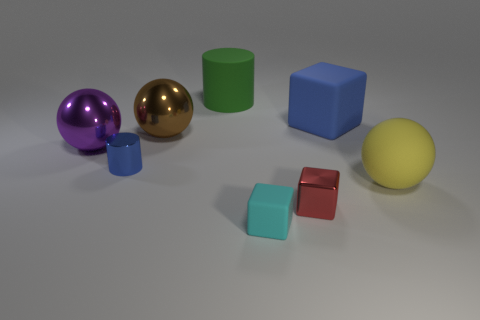Can you describe the lighting in the scene? The lighting in the scene appears to be coming from above, casting soft shadows directly underneath the objects. This type of lighting is often used to create a neutral, diffused effect, minimizing harsh shadows and allowing the colors and textures of the objects to be seen clearly. 